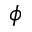<formula> <loc_0><loc_0><loc_500><loc_500>\phi</formula> 